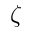Convert formula to latex. <formula><loc_0><loc_0><loc_500><loc_500>\zeta</formula> 